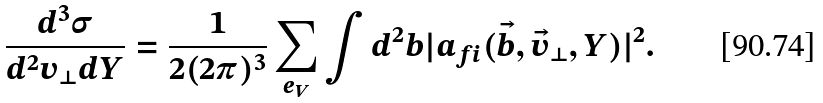Convert formula to latex. <formula><loc_0><loc_0><loc_500><loc_500>\frac { d ^ { 3 } \sigma } { d ^ { 2 } v _ { \perp } d Y } = \frac { 1 } { 2 ( 2 \pi ) ^ { 3 } } \sum _ { e _ { V } } \int d ^ { 2 } b | a _ { f i } ( \vec { b } , \vec { v } _ { \perp } , Y ) | ^ { 2 } .</formula> 